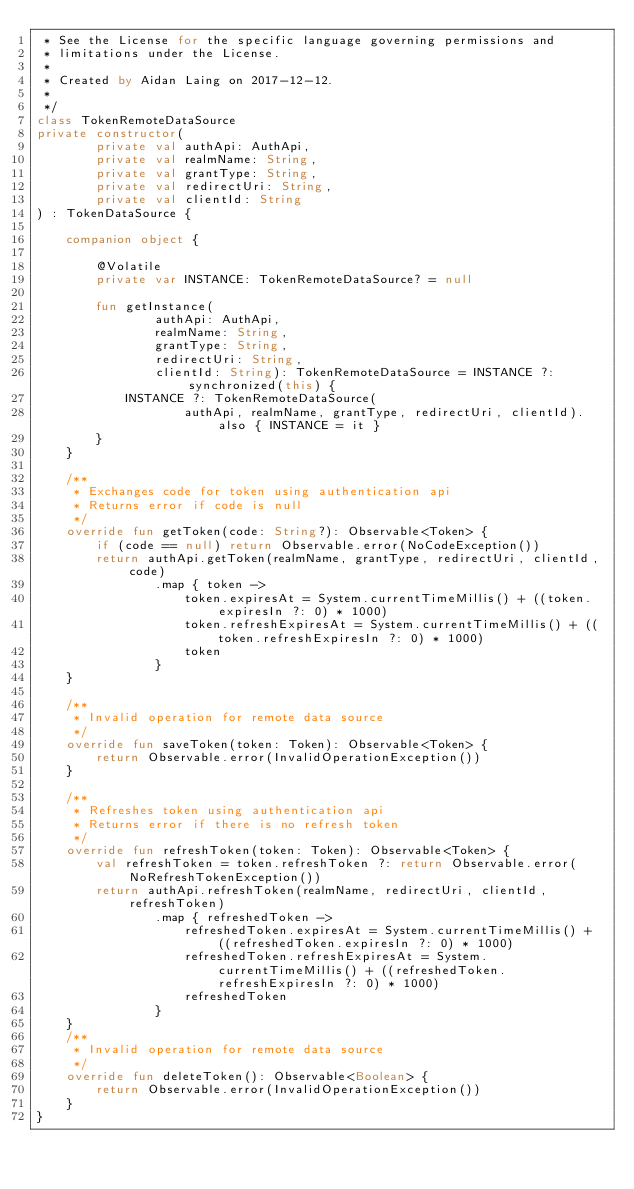Convert code to text. <code><loc_0><loc_0><loc_500><loc_500><_Kotlin_> * See the License for the specific language governing permissions and
 * limitations under the License.
 *
 * Created by Aidan Laing on 2017-12-12.
 *
 */
class TokenRemoteDataSource
private constructor(
        private val authApi: AuthApi,
        private val realmName: String,
        private val grantType: String,
        private val redirectUri: String,
        private val clientId: String
) : TokenDataSource {

    companion object {

        @Volatile
        private var INSTANCE: TokenRemoteDataSource? = null

        fun getInstance(
                authApi: AuthApi,
                realmName: String,
                grantType: String,
                redirectUri: String,
                clientId: String): TokenRemoteDataSource = INSTANCE ?: synchronized(this) {
            INSTANCE ?: TokenRemoteDataSource(
                    authApi, realmName, grantType, redirectUri, clientId).also { INSTANCE = it }
        }
    }

    /**
     * Exchanges code for token using authentication api
     * Returns error if code is null
     */
    override fun getToken(code: String?): Observable<Token> {
        if (code == null) return Observable.error(NoCodeException())
        return authApi.getToken(realmName, grantType, redirectUri, clientId, code)
                .map { token ->
                    token.expiresAt = System.currentTimeMillis() + ((token.expiresIn ?: 0) * 1000)
                    token.refreshExpiresAt = System.currentTimeMillis() + ((token.refreshExpiresIn ?: 0) * 1000)
                    token
                }
    }

    /**
     * Invalid operation for remote data source
     */
    override fun saveToken(token: Token): Observable<Token> {
        return Observable.error(InvalidOperationException())
    }

    /**
     * Refreshes token using authentication api
     * Returns error if there is no refresh token
     */
    override fun refreshToken(token: Token): Observable<Token> {
        val refreshToken = token.refreshToken ?: return Observable.error(NoRefreshTokenException())
        return authApi.refreshToken(realmName, redirectUri, clientId, refreshToken)
                .map { refreshedToken ->
                    refreshedToken.expiresAt = System.currentTimeMillis() + ((refreshedToken.expiresIn ?: 0) * 1000)
                    refreshedToken.refreshExpiresAt = System.currentTimeMillis() + ((refreshedToken.refreshExpiresIn ?: 0) * 1000)
                    refreshedToken
                }
    }
    /**
     * Invalid operation for remote data source
     */
    override fun deleteToken(): Observable<Boolean> {
        return Observable.error(InvalidOperationException())
    }
}</code> 